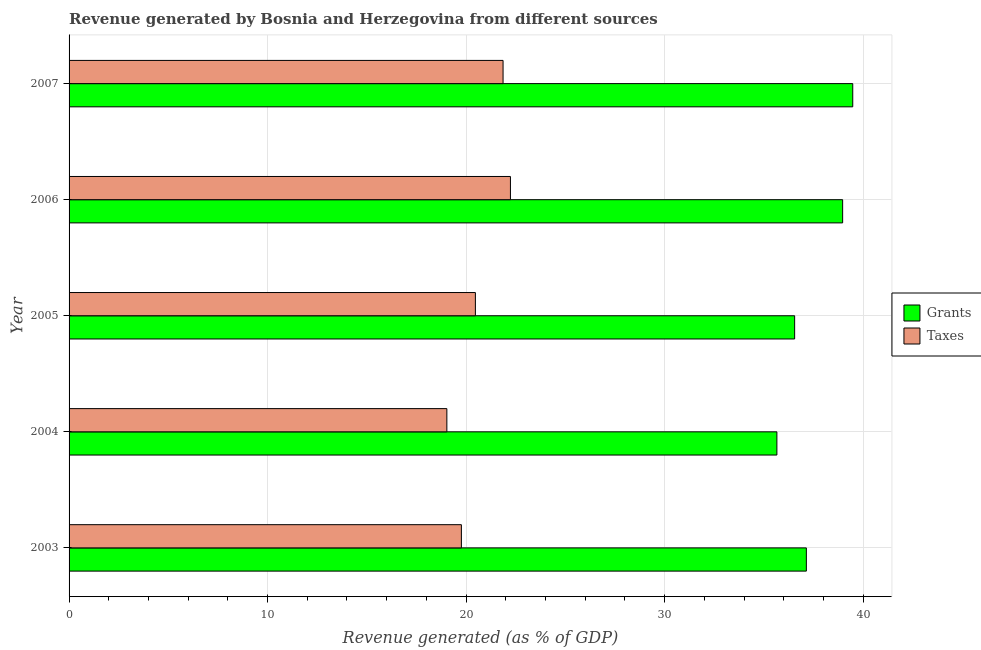Are the number of bars on each tick of the Y-axis equal?
Your answer should be very brief. Yes. How many bars are there on the 4th tick from the top?
Your answer should be very brief. 2. How many bars are there on the 3rd tick from the bottom?
Your response must be concise. 2. In how many cases, is the number of bars for a given year not equal to the number of legend labels?
Your response must be concise. 0. What is the revenue generated by grants in 2006?
Provide a succinct answer. 38.97. Across all years, what is the maximum revenue generated by taxes?
Provide a succinct answer. 22.23. Across all years, what is the minimum revenue generated by taxes?
Ensure brevity in your answer.  19.03. In which year was the revenue generated by taxes minimum?
Give a very brief answer. 2004. What is the total revenue generated by taxes in the graph?
Your response must be concise. 103.36. What is the difference between the revenue generated by taxes in 2006 and that in 2007?
Offer a very short reply. 0.37. What is the difference between the revenue generated by taxes in 2004 and the revenue generated by grants in 2005?
Offer a terse response. -17.52. What is the average revenue generated by taxes per year?
Ensure brevity in your answer.  20.67. In the year 2006, what is the difference between the revenue generated by grants and revenue generated by taxes?
Make the answer very short. 16.73. What is the ratio of the revenue generated by taxes in 2005 to that in 2007?
Provide a succinct answer. 0.94. What is the difference between the highest and the second highest revenue generated by grants?
Provide a short and direct response. 0.51. What is the difference between the highest and the lowest revenue generated by taxes?
Your answer should be compact. 3.2. Is the sum of the revenue generated by taxes in 2006 and 2007 greater than the maximum revenue generated by grants across all years?
Offer a terse response. Yes. What does the 1st bar from the top in 2003 represents?
Offer a very short reply. Taxes. What does the 2nd bar from the bottom in 2005 represents?
Provide a succinct answer. Taxes. Are all the bars in the graph horizontal?
Offer a terse response. Yes. How many years are there in the graph?
Ensure brevity in your answer.  5. What is the difference between two consecutive major ticks on the X-axis?
Provide a short and direct response. 10. Does the graph contain grids?
Ensure brevity in your answer.  Yes. Where does the legend appear in the graph?
Offer a terse response. Center right. How many legend labels are there?
Offer a terse response. 2. How are the legend labels stacked?
Give a very brief answer. Vertical. What is the title of the graph?
Your answer should be compact. Revenue generated by Bosnia and Herzegovina from different sources. Does "Commercial service imports" appear as one of the legend labels in the graph?
Provide a succinct answer. No. What is the label or title of the X-axis?
Provide a succinct answer. Revenue generated (as % of GDP). What is the Revenue generated (as % of GDP) of Grants in 2003?
Make the answer very short. 37.14. What is the Revenue generated (as % of GDP) in Taxes in 2003?
Provide a succinct answer. 19.76. What is the Revenue generated (as % of GDP) in Grants in 2004?
Offer a terse response. 35.66. What is the Revenue generated (as % of GDP) in Taxes in 2004?
Keep it short and to the point. 19.03. What is the Revenue generated (as % of GDP) of Grants in 2005?
Provide a succinct answer. 36.55. What is the Revenue generated (as % of GDP) of Taxes in 2005?
Provide a short and direct response. 20.47. What is the Revenue generated (as % of GDP) of Grants in 2006?
Your response must be concise. 38.97. What is the Revenue generated (as % of GDP) in Taxes in 2006?
Provide a short and direct response. 22.23. What is the Revenue generated (as % of GDP) of Grants in 2007?
Your answer should be compact. 39.48. What is the Revenue generated (as % of GDP) of Taxes in 2007?
Make the answer very short. 21.86. Across all years, what is the maximum Revenue generated (as % of GDP) of Grants?
Your response must be concise. 39.48. Across all years, what is the maximum Revenue generated (as % of GDP) in Taxes?
Give a very brief answer. 22.23. Across all years, what is the minimum Revenue generated (as % of GDP) of Grants?
Offer a very short reply. 35.66. Across all years, what is the minimum Revenue generated (as % of GDP) in Taxes?
Offer a terse response. 19.03. What is the total Revenue generated (as % of GDP) in Grants in the graph?
Offer a very short reply. 187.79. What is the total Revenue generated (as % of GDP) of Taxes in the graph?
Your response must be concise. 103.36. What is the difference between the Revenue generated (as % of GDP) of Grants in 2003 and that in 2004?
Offer a very short reply. 1.48. What is the difference between the Revenue generated (as % of GDP) in Taxes in 2003 and that in 2004?
Offer a terse response. 0.73. What is the difference between the Revenue generated (as % of GDP) in Grants in 2003 and that in 2005?
Keep it short and to the point. 0.59. What is the difference between the Revenue generated (as % of GDP) in Taxes in 2003 and that in 2005?
Ensure brevity in your answer.  -0.71. What is the difference between the Revenue generated (as % of GDP) in Grants in 2003 and that in 2006?
Your response must be concise. -1.83. What is the difference between the Revenue generated (as % of GDP) in Taxes in 2003 and that in 2006?
Offer a terse response. -2.47. What is the difference between the Revenue generated (as % of GDP) in Grants in 2003 and that in 2007?
Provide a succinct answer. -2.34. What is the difference between the Revenue generated (as % of GDP) of Taxes in 2003 and that in 2007?
Give a very brief answer. -2.1. What is the difference between the Revenue generated (as % of GDP) of Grants in 2004 and that in 2005?
Your answer should be very brief. -0.89. What is the difference between the Revenue generated (as % of GDP) in Taxes in 2004 and that in 2005?
Offer a very short reply. -1.44. What is the difference between the Revenue generated (as % of GDP) in Grants in 2004 and that in 2006?
Provide a short and direct response. -3.31. What is the difference between the Revenue generated (as % of GDP) in Taxes in 2004 and that in 2006?
Your response must be concise. -3.2. What is the difference between the Revenue generated (as % of GDP) in Grants in 2004 and that in 2007?
Make the answer very short. -3.82. What is the difference between the Revenue generated (as % of GDP) of Taxes in 2004 and that in 2007?
Make the answer very short. -2.83. What is the difference between the Revenue generated (as % of GDP) of Grants in 2005 and that in 2006?
Your answer should be very brief. -2.42. What is the difference between the Revenue generated (as % of GDP) in Taxes in 2005 and that in 2006?
Provide a succinct answer. -1.77. What is the difference between the Revenue generated (as % of GDP) in Grants in 2005 and that in 2007?
Your response must be concise. -2.93. What is the difference between the Revenue generated (as % of GDP) of Taxes in 2005 and that in 2007?
Give a very brief answer. -1.39. What is the difference between the Revenue generated (as % of GDP) in Grants in 2006 and that in 2007?
Ensure brevity in your answer.  -0.51. What is the difference between the Revenue generated (as % of GDP) of Taxes in 2006 and that in 2007?
Provide a short and direct response. 0.37. What is the difference between the Revenue generated (as % of GDP) in Grants in 2003 and the Revenue generated (as % of GDP) in Taxes in 2004?
Make the answer very short. 18.11. What is the difference between the Revenue generated (as % of GDP) of Grants in 2003 and the Revenue generated (as % of GDP) of Taxes in 2005?
Offer a very short reply. 16.67. What is the difference between the Revenue generated (as % of GDP) of Grants in 2003 and the Revenue generated (as % of GDP) of Taxes in 2006?
Make the answer very short. 14.91. What is the difference between the Revenue generated (as % of GDP) of Grants in 2003 and the Revenue generated (as % of GDP) of Taxes in 2007?
Provide a succinct answer. 15.28. What is the difference between the Revenue generated (as % of GDP) of Grants in 2004 and the Revenue generated (as % of GDP) of Taxes in 2005?
Give a very brief answer. 15.19. What is the difference between the Revenue generated (as % of GDP) in Grants in 2004 and the Revenue generated (as % of GDP) in Taxes in 2006?
Offer a terse response. 13.42. What is the difference between the Revenue generated (as % of GDP) of Grants in 2004 and the Revenue generated (as % of GDP) of Taxes in 2007?
Provide a succinct answer. 13.79. What is the difference between the Revenue generated (as % of GDP) of Grants in 2005 and the Revenue generated (as % of GDP) of Taxes in 2006?
Offer a terse response. 14.32. What is the difference between the Revenue generated (as % of GDP) of Grants in 2005 and the Revenue generated (as % of GDP) of Taxes in 2007?
Make the answer very short. 14.69. What is the difference between the Revenue generated (as % of GDP) in Grants in 2006 and the Revenue generated (as % of GDP) in Taxes in 2007?
Make the answer very short. 17.11. What is the average Revenue generated (as % of GDP) in Grants per year?
Offer a very short reply. 37.56. What is the average Revenue generated (as % of GDP) in Taxes per year?
Give a very brief answer. 20.67. In the year 2003, what is the difference between the Revenue generated (as % of GDP) of Grants and Revenue generated (as % of GDP) of Taxes?
Ensure brevity in your answer.  17.38. In the year 2004, what is the difference between the Revenue generated (as % of GDP) in Grants and Revenue generated (as % of GDP) in Taxes?
Your answer should be very brief. 16.62. In the year 2005, what is the difference between the Revenue generated (as % of GDP) in Grants and Revenue generated (as % of GDP) in Taxes?
Ensure brevity in your answer.  16.08. In the year 2006, what is the difference between the Revenue generated (as % of GDP) of Grants and Revenue generated (as % of GDP) of Taxes?
Ensure brevity in your answer.  16.73. In the year 2007, what is the difference between the Revenue generated (as % of GDP) of Grants and Revenue generated (as % of GDP) of Taxes?
Ensure brevity in your answer.  17.62. What is the ratio of the Revenue generated (as % of GDP) of Grants in 2003 to that in 2004?
Keep it short and to the point. 1.04. What is the ratio of the Revenue generated (as % of GDP) in Grants in 2003 to that in 2005?
Offer a very short reply. 1.02. What is the ratio of the Revenue generated (as % of GDP) in Taxes in 2003 to that in 2005?
Offer a terse response. 0.97. What is the ratio of the Revenue generated (as % of GDP) of Grants in 2003 to that in 2006?
Provide a short and direct response. 0.95. What is the ratio of the Revenue generated (as % of GDP) in Grants in 2003 to that in 2007?
Offer a terse response. 0.94. What is the ratio of the Revenue generated (as % of GDP) of Taxes in 2003 to that in 2007?
Your answer should be very brief. 0.9. What is the ratio of the Revenue generated (as % of GDP) of Grants in 2004 to that in 2005?
Give a very brief answer. 0.98. What is the ratio of the Revenue generated (as % of GDP) of Taxes in 2004 to that in 2005?
Provide a short and direct response. 0.93. What is the ratio of the Revenue generated (as % of GDP) in Grants in 2004 to that in 2006?
Make the answer very short. 0.92. What is the ratio of the Revenue generated (as % of GDP) in Taxes in 2004 to that in 2006?
Your answer should be very brief. 0.86. What is the ratio of the Revenue generated (as % of GDP) in Grants in 2004 to that in 2007?
Your answer should be very brief. 0.9. What is the ratio of the Revenue generated (as % of GDP) of Taxes in 2004 to that in 2007?
Give a very brief answer. 0.87. What is the ratio of the Revenue generated (as % of GDP) of Grants in 2005 to that in 2006?
Give a very brief answer. 0.94. What is the ratio of the Revenue generated (as % of GDP) of Taxes in 2005 to that in 2006?
Offer a terse response. 0.92. What is the ratio of the Revenue generated (as % of GDP) of Grants in 2005 to that in 2007?
Make the answer very short. 0.93. What is the ratio of the Revenue generated (as % of GDP) in Taxes in 2005 to that in 2007?
Offer a terse response. 0.94. What is the ratio of the Revenue generated (as % of GDP) of Grants in 2006 to that in 2007?
Give a very brief answer. 0.99. What is the ratio of the Revenue generated (as % of GDP) in Taxes in 2006 to that in 2007?
Keep it short and to the point. 1.02. What is the difference between the highest and the second highest Revenue generated (as % of GDP) in Grants?
Your response must be concise. 0.51. What is the difference between the highest and the second highest Revenue generated (as % of GDP) in Taxes?
Your answer should be very brief. 0.37. What is the difference between the highest and the lowest Revenue generated (as % of GDP) of Grants?
Make the answer very short. 3.82. What is the difference between the highest and the lowest Revenue generated (as % of GDP) in Taxes?
Ensure brevity in your answer.  3.2. 